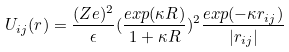<formula> <loc_0><loc_0><loc_500><loc_500>U _ { i j } ( r ) = \frac { ( Z e ) ^ { 2 } } { \epsilon } ( \frac { e x p ( \kappa R ) } { 1 + \kappa R } ) ^ { 2 } \frac { e x p ( - \kappa r _ { i j } ) } { | r _ { i j } | }</formula> 